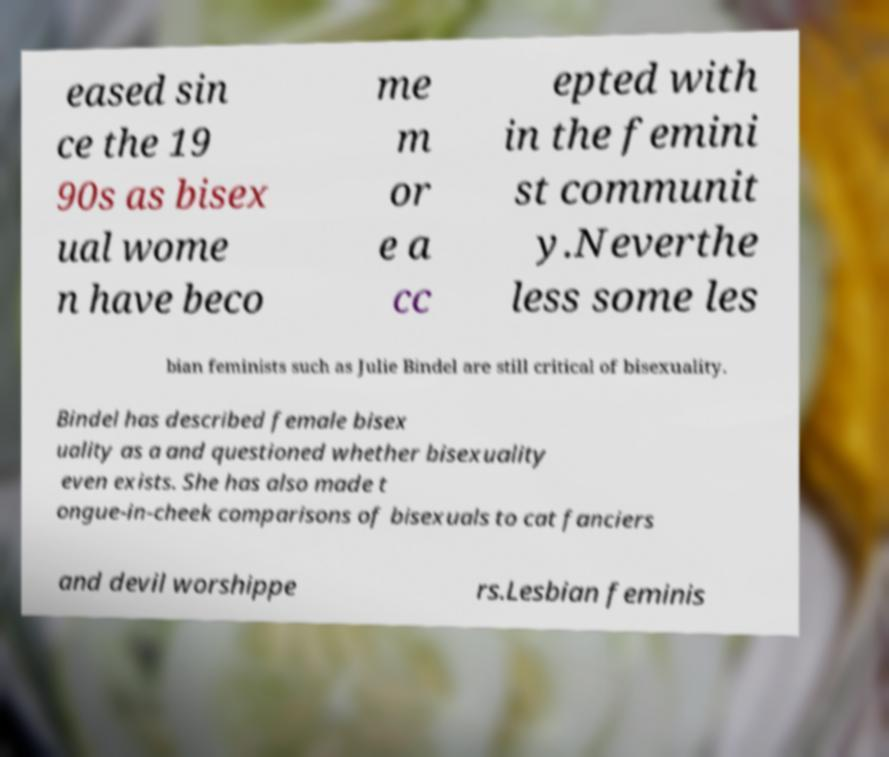What messages or text are displayed in this image? I need them in a readable, typed format. eased sin ce the 19 90s as bisex ual wome n have beco me m or e a cc epted with in the femini st communit y.Neverthe less some les bian feminists such as Julie Bindel are still critical of bisexuality. Bindel has described female bisex uality as a and questioned whether bisexuality even exists. She has also made t ongue-in-cheek comparisons of bisexuals to cat fanciers and devil worshippe rs.Lesbian feminis 